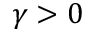Convert formula to latex. <formula><loc_0><loc_0><loc_500><loc_500>\gamma > 0</formula> 